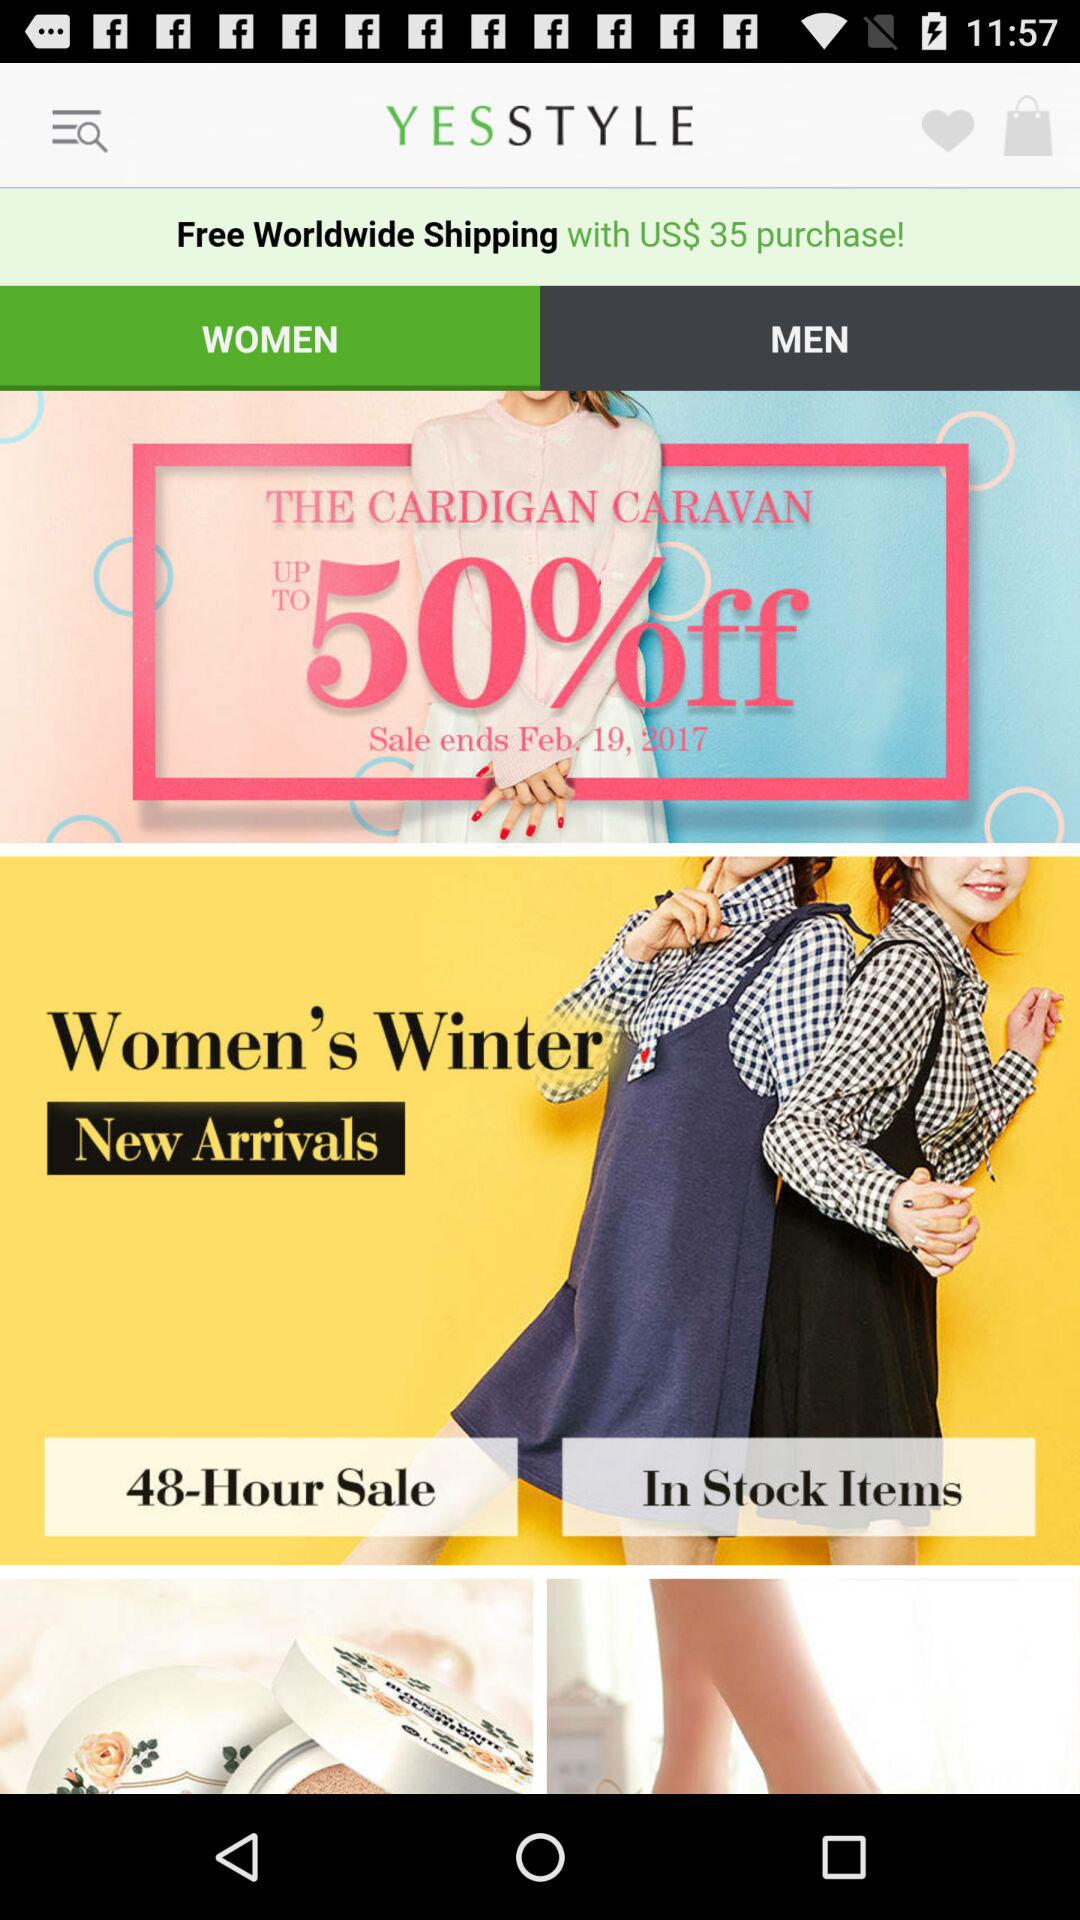Is worldwide shipping paid or free with the purchase of US$35? With the purchase of US$35, worldwide shipping is free. 